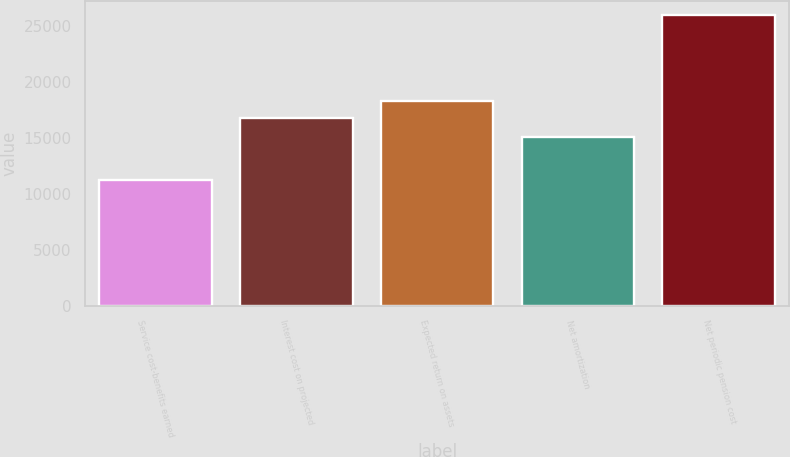<chart> <loc_0><loc_0><loc_500><loc_500><bar_chart><fcel>Service cost-benefits earned<fcel>Interest cost on projected<fcel>Expected return on assets<fcel>Net amortization<fcel>Net periodic pension cost<nl><fcel>11215<fcel>16796<fcel>18275.2<fcel>15110<fcel>26007<nl></chart> 